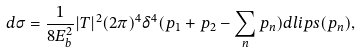<formula> <loc_0><loc_0><loc_500><loc_500>d \sigma = \frac { 1 } { 8 E ^ { 2 } _ { b } } | T | ^ { 2 } ( 2 \pi ) ^ { 4 } \delta ^ { 4 } ( p _ { 1 } + p _ { 2 } - \sum _ { n } p _ { n } ) d l i p s ( p _ { n } ) ,</formula> 